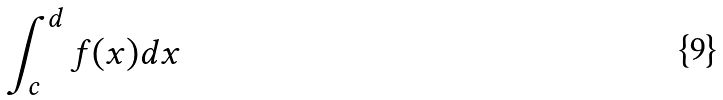Convert formula to latex. <formula><loc_0><loc_0><loc_500><loc_500>\int _ { c } ^ { d } f ( x ) d x</formula> 